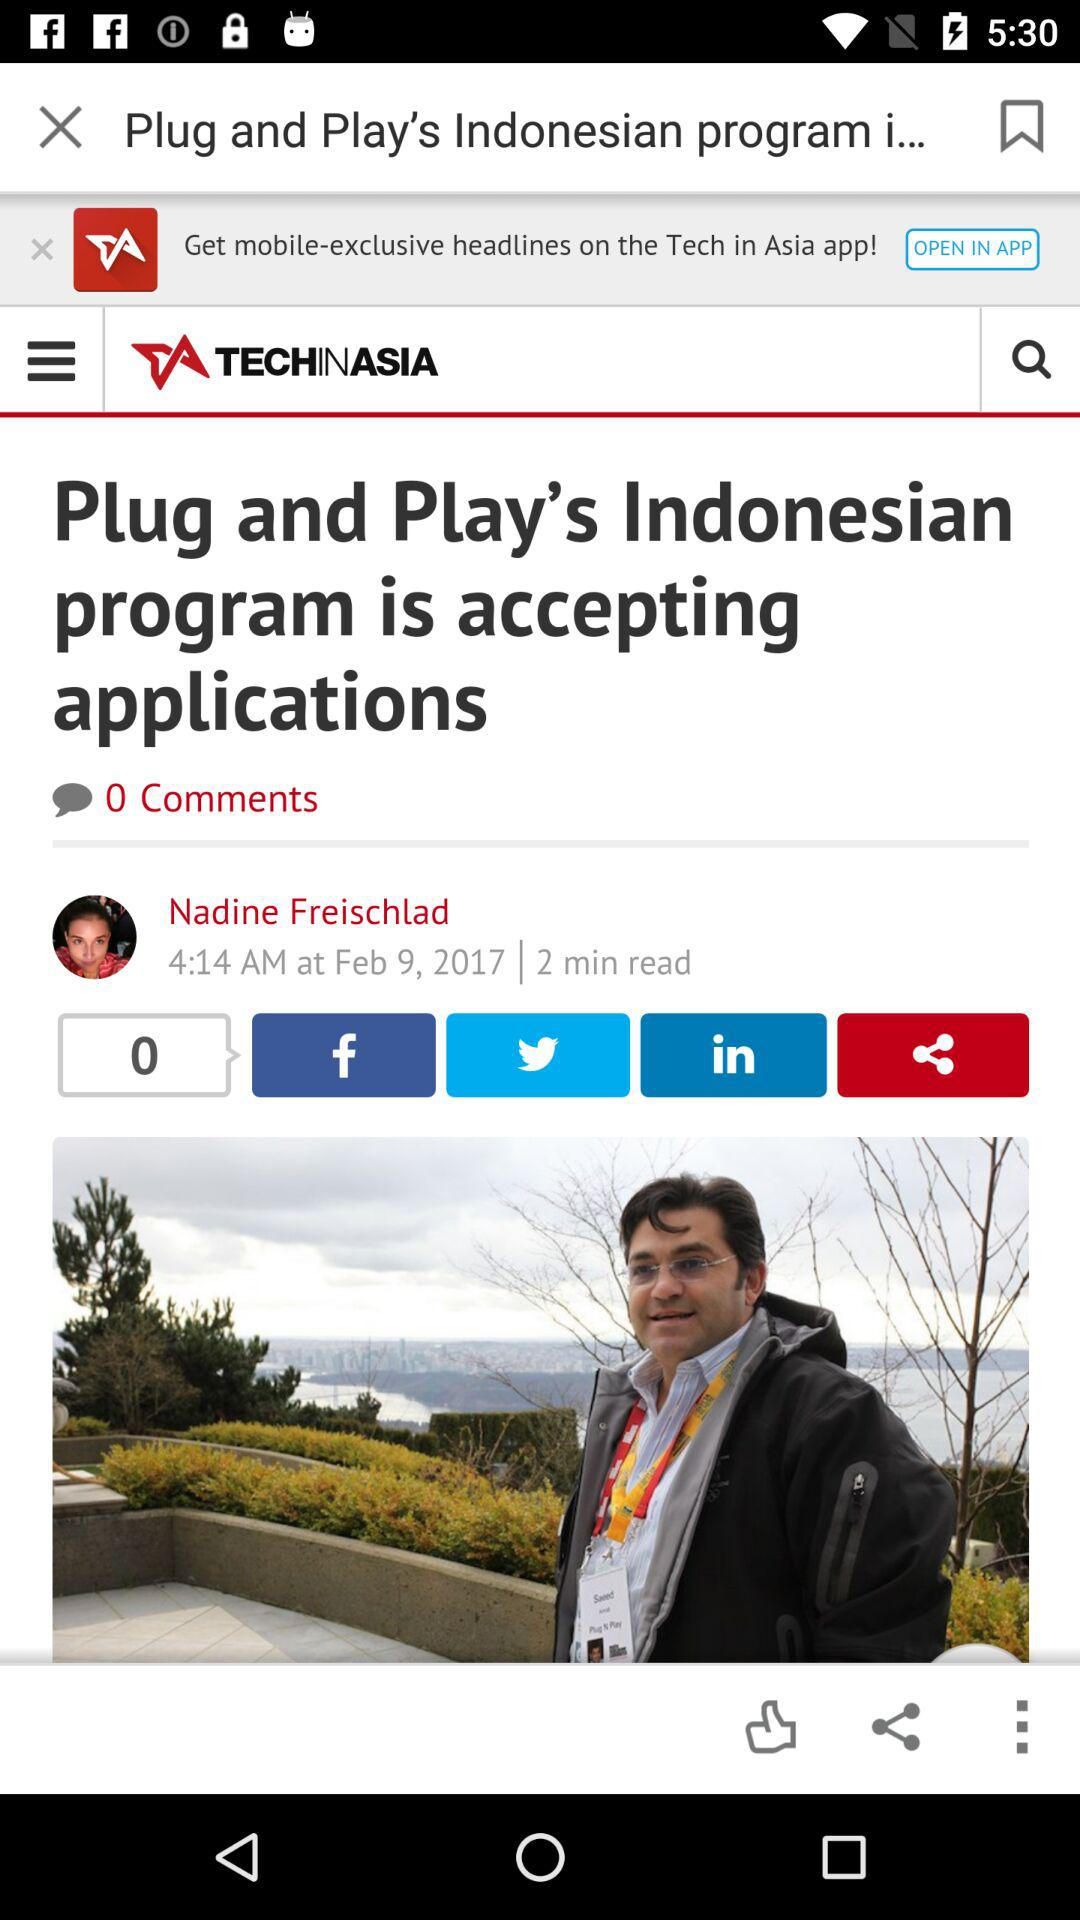What is the application name? The application name is "TECHINASIA". 